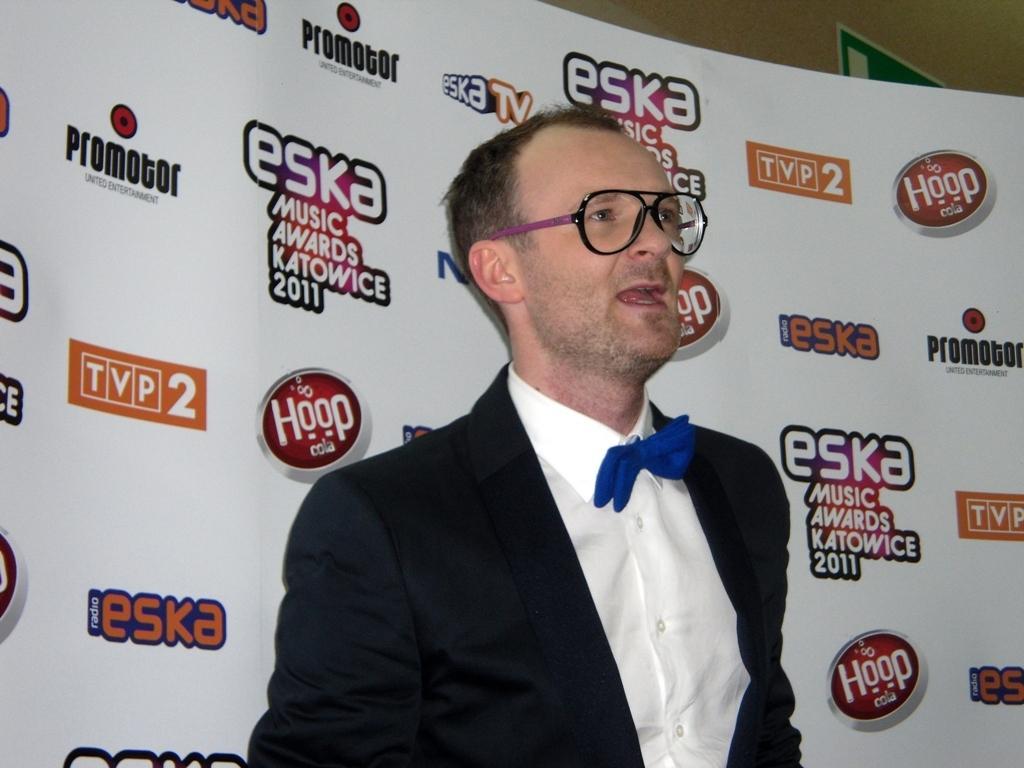Describe this image in one or two sentences. In this picture I can observe a man wearing black color coat, blue color bow tie and spectacles. Behind him there is a poster. I can observe some text on the poster. In the background there is a wall. 